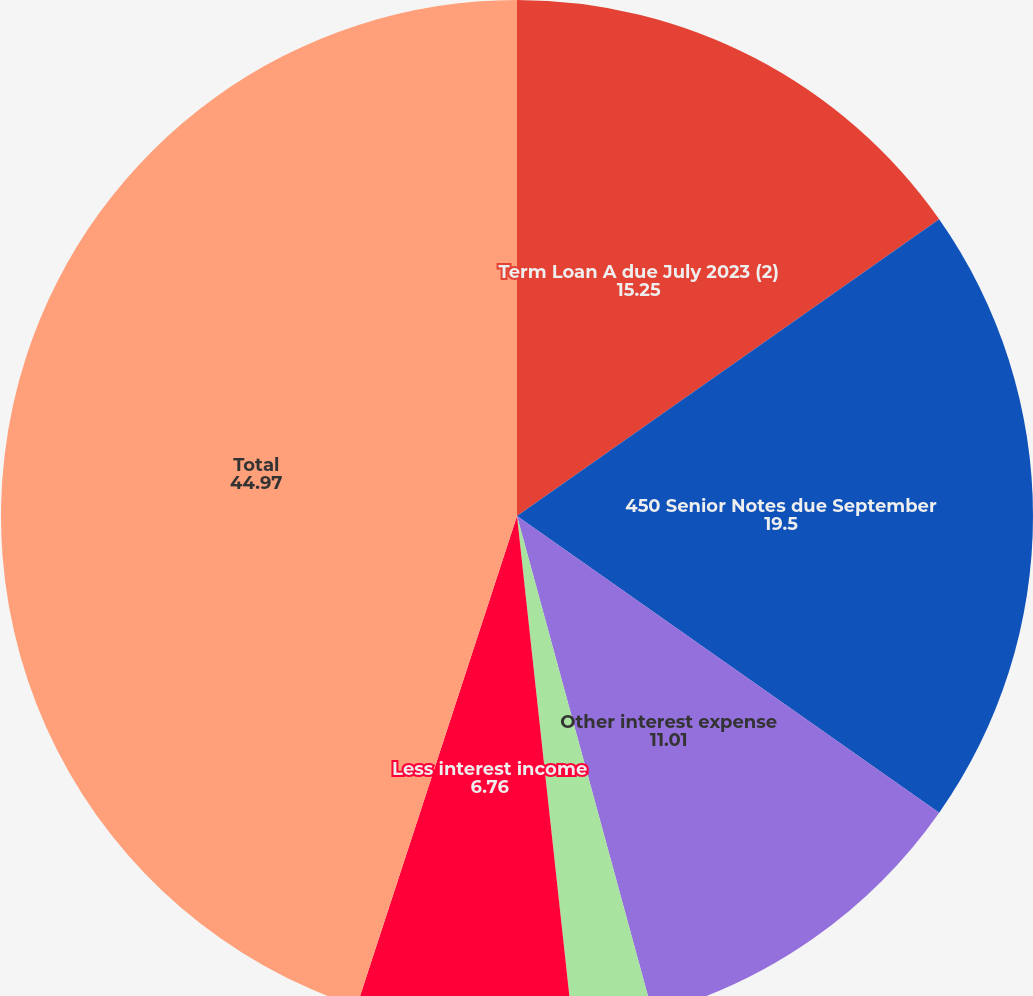<chart> <loc_0><loc_0><loc_500><loc_500><pie_chart><fcel>Term Loan A due July 2023 (2)<fcel>450 Senior Notes due September<fcel>Other interest expense<fcel>Less capitalized interest<fcel>Less interest income<fcel>Total<nl><fcel>15.25%<fcel>19.5%<fcel>11.01%<fcel>2.51%<fcel>6.76%<fcel>44.97%<nl></chart> 